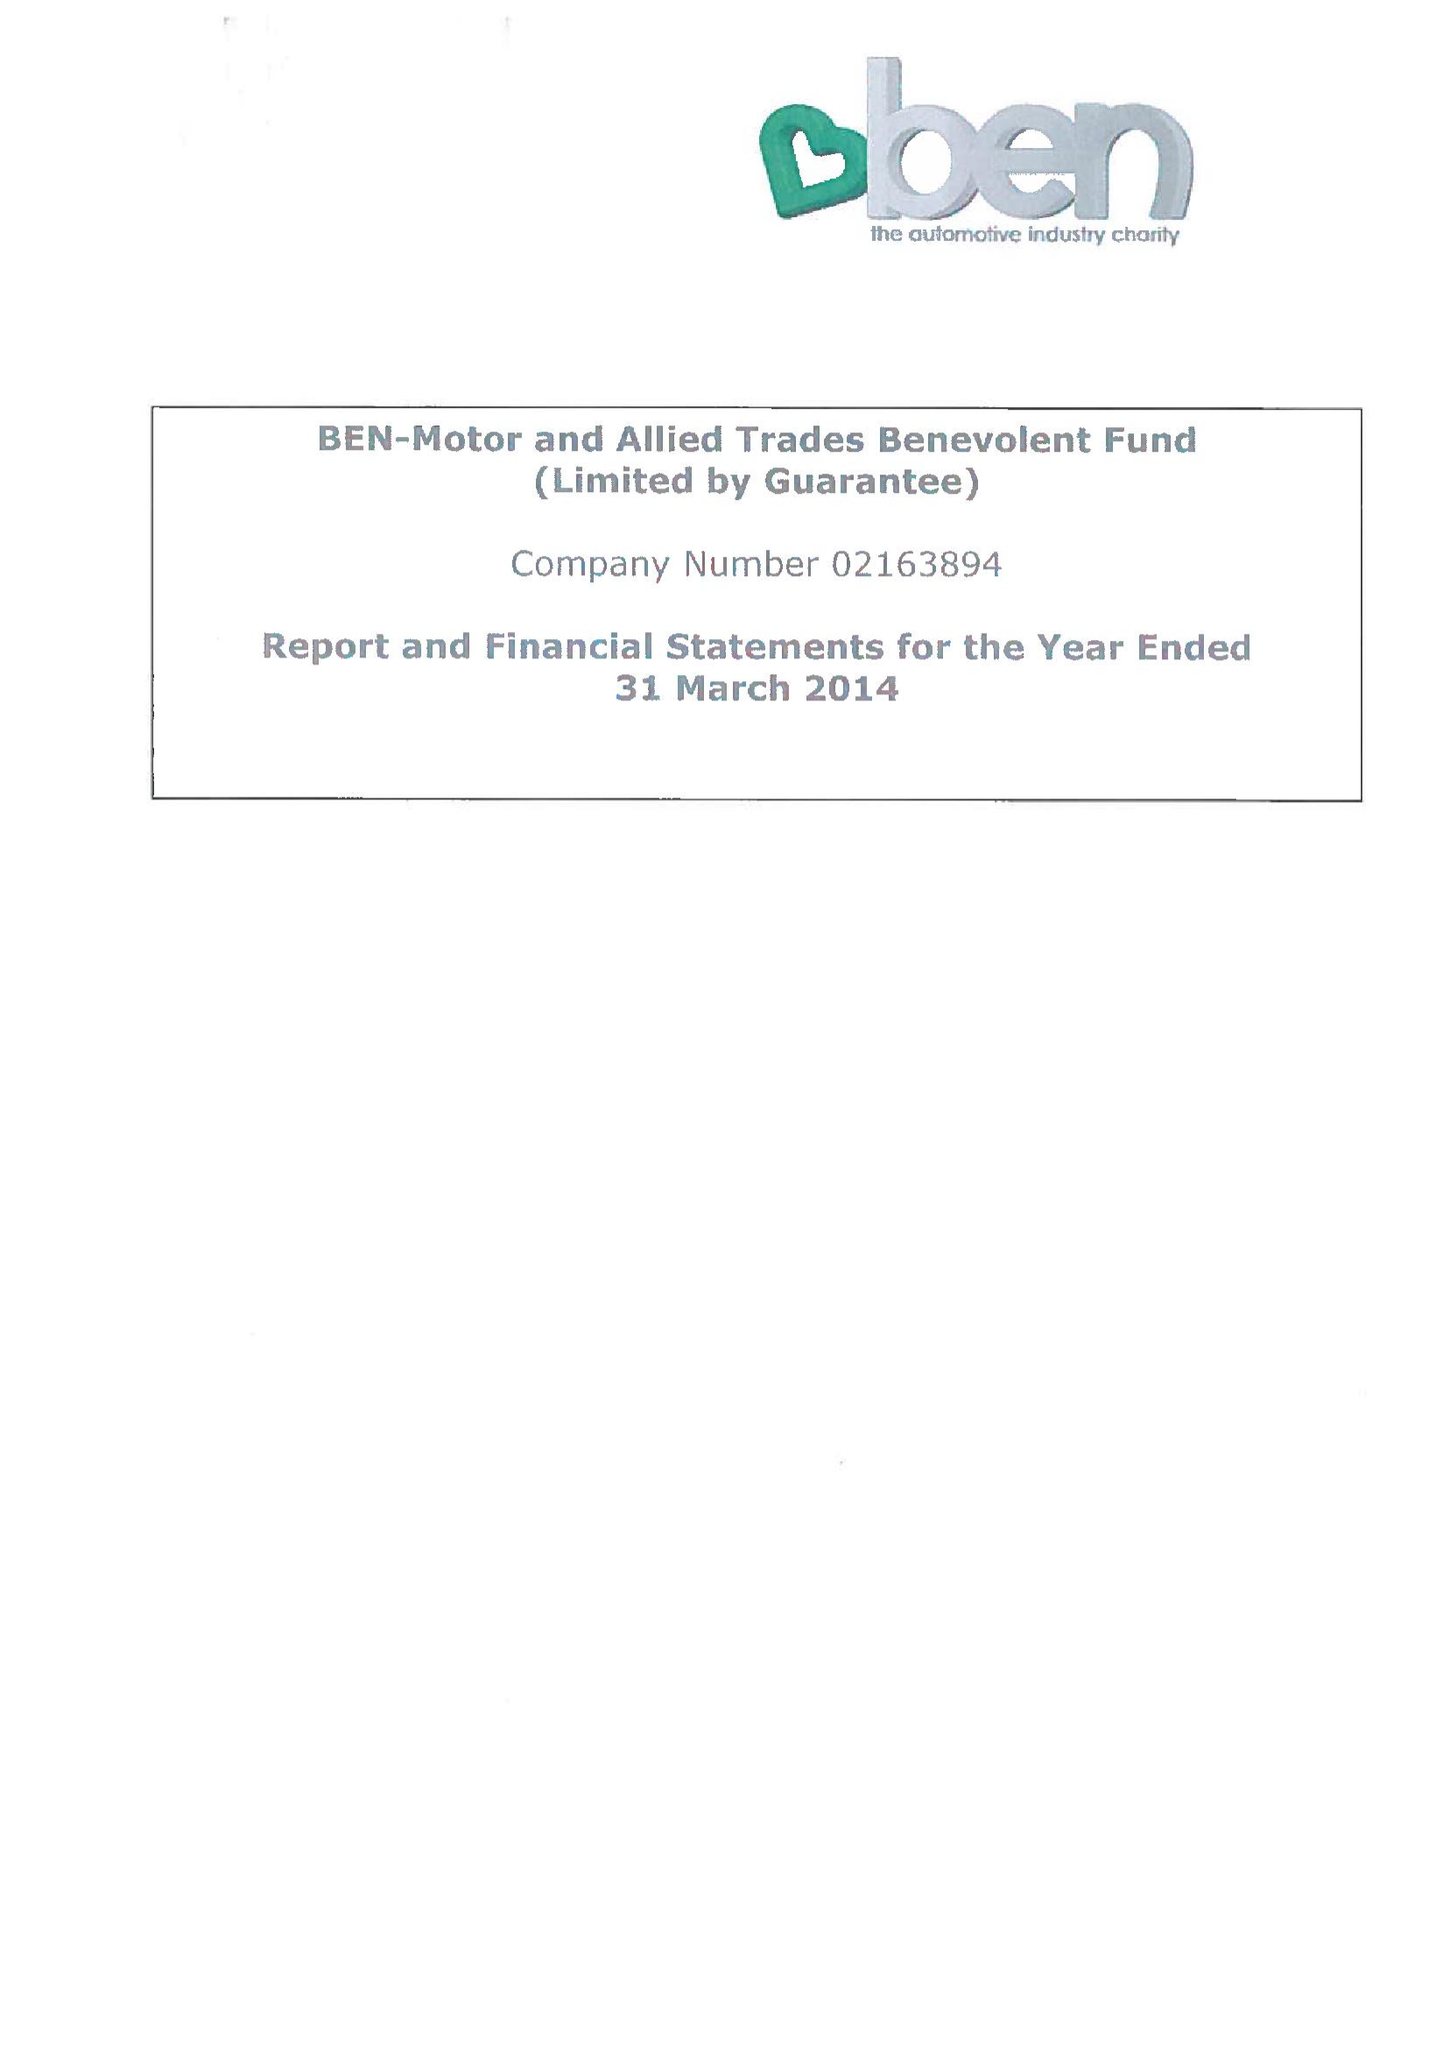What is the value for the spending_annually_in_british_pounds?
Answer the question using a single word or phrase. 11375381.00 